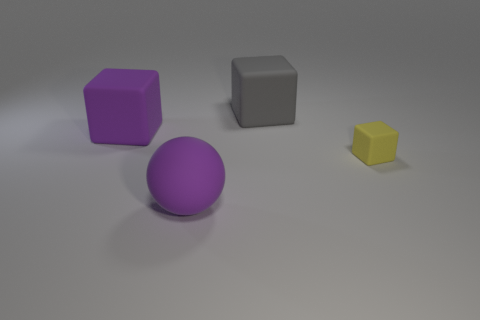Add 3 tiny matte cubes. How many objects exist? 7 Subtract all cubes. How many objects are left? 1 Add 3 tiny rubber things. How many tiny rubber things exist? 4 Subtract 0 green cylinders. How many objects are left? 4 Subtract all small yellow matte things. Subtract all purple rubber spheres. How many objects are left? 2 Add 2 big matte objects. How many big matte objects are left? 5 